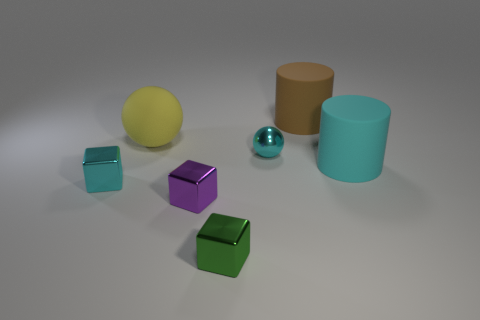What material is the large cylinder that is the same color as the small sphere?
Make the answer very short. Rubber. There is a object on the left side of the yellow matte sphere; does it have the same color as the tiny sphere?
Keep it short and to the point. Yes. Are there fewer small green shiny things than metallic cubes?
Your answer should be compact. Yes. What number of other objects are the same color as the tiny ball?
Provide a short and direct response. 2. Is the sphere on the right side of the small green metallic thing made of the same material as the small cyan block?
Offer a terse response. Yes. There is a cyan object to the left of the yellow thing; what is it made of?
Provide a succinct answer. Metal. What size is the cyan object behind the rubber cylinder in front of the brown rubber cylinder?
Offer a very short reply. Small. Is there a block that has the same material as the tiny cyan sphere?
Provide a succinct answer. Yes. There is a big matte object that is in front of the tiny cyan shiny thing on the right side of the tiny cyan shiny thing on the left side of the big yellow ball; what is its shape?
Keep it short and to the point. Cylinder. Do the big matte cylinder that is in front of the brown cylinder and the small metal block that is behind the purple metal thing have the same color?
Offer a terse response. Yes. 